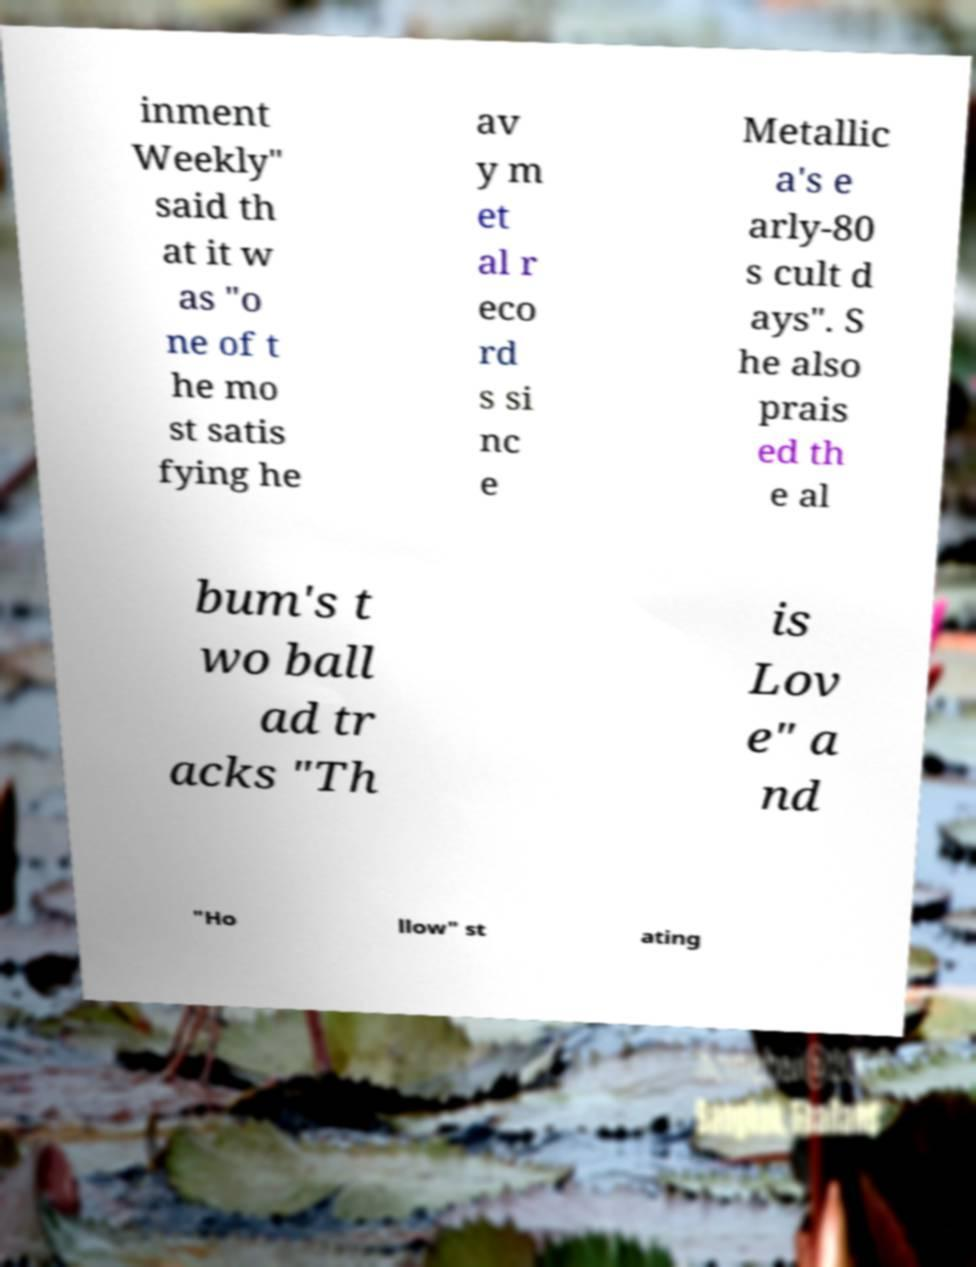Please read and relay the text visible in this image. What does it say? inment Weekly" said th at it w as "o ne of t he mo st satis fying he av y m et al r eco rd s si nc e Metallic a's e arly-80 s cult d ays". S he also prais ed th e al bum's t wo ball ad tr acks "Th is Lov e" a nd "Ho llow" st ating 